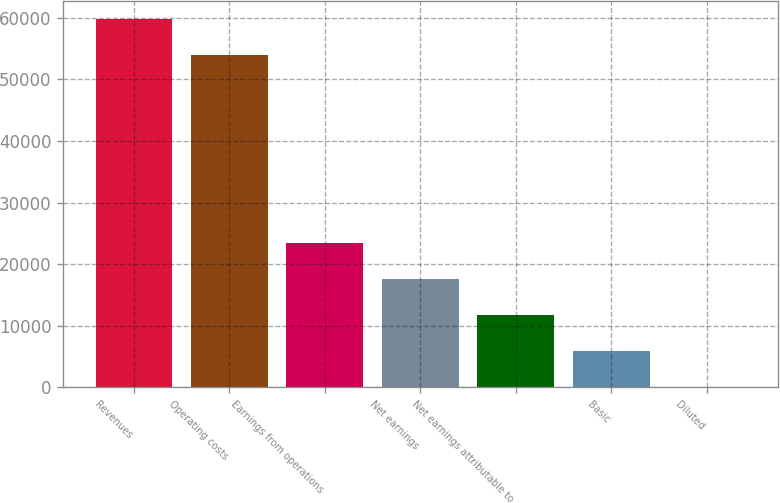Convert chart to OTSL. <chart><loc_0><loc_0><loc_500><loc_500><bar_chart><fcel>Revenues<fcel>Operating costs<fcel>Earnings from operations<fcel>Net earnings<fcel>Net earnings attributable to<fcel>Basic<fcel>Diluted<nl><fcel>59761.4<fcel>53920<fcel>23368.7<fcel>17527.3<fcel>11685.9<fcel>5844.49<fcel>3.1<nl></chart> 